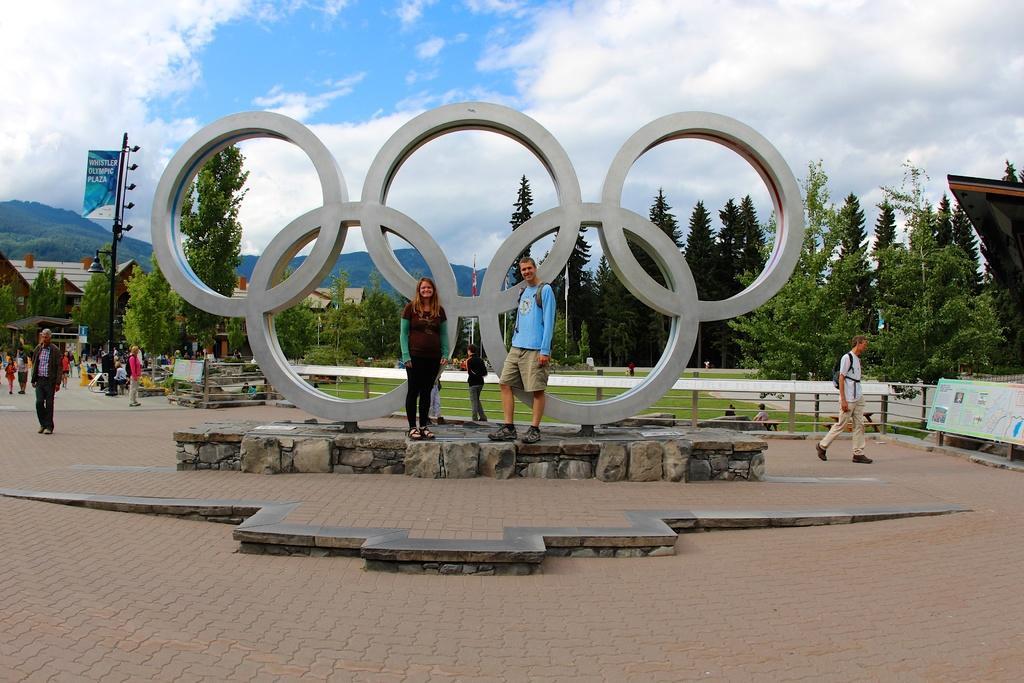Can you describe this image briefly? In this image there are rings in the center, and there are two people standing. And the some of them are walking, at the bottom there is a walkway and in the background there are trees, poles, flags, houses and mountains and some boards. At the top of the image there is sky. 